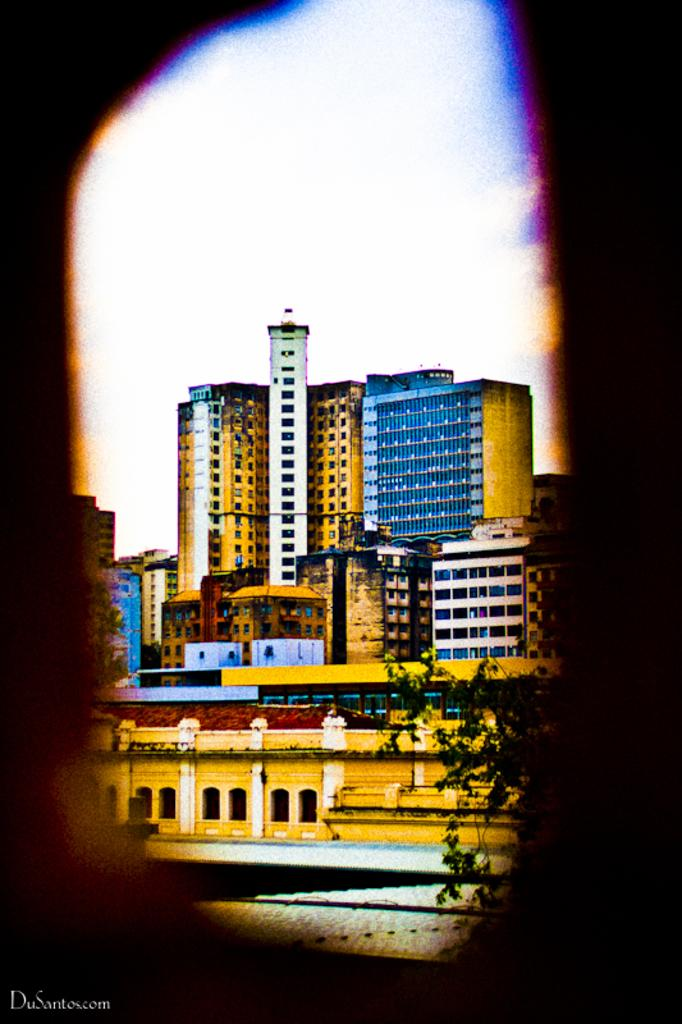What type of structures can be seen in the image? There are buildings in the image. What feature can be observed on the buildings? There are windows visible in the image. What type of vegetation is present in the image? There are trees in the image. What is visible in the background of the image? The sky is visible in the background of the image. What type of furniture is visible in the image? There is no furniture present in the image. Who is the representative of the buildings in the image? The image does not depict a representative of the buildings; it simply shows the buildings themselves. 